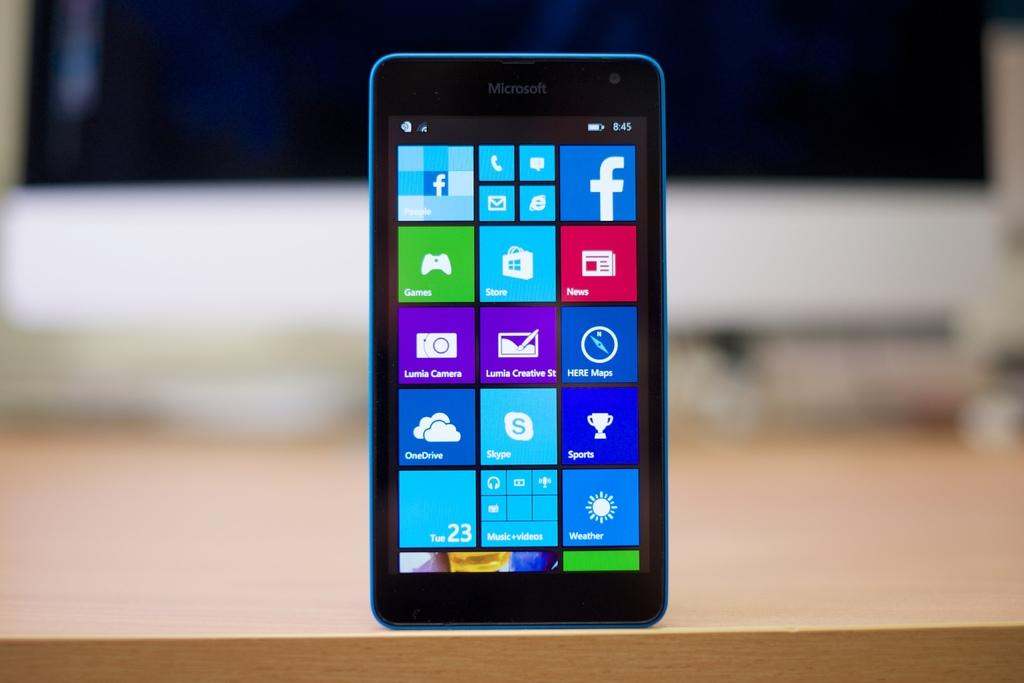<image>
Give a short and clear explanation of the subsequent image. a blue nokia phone with a black rim and with the games app icon on the screen 